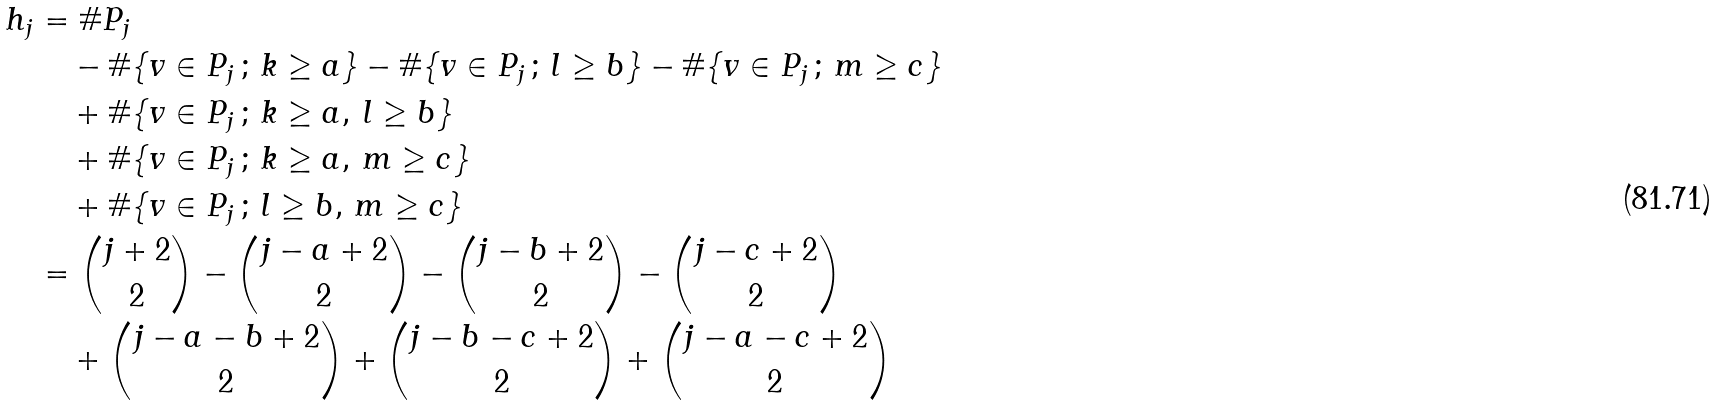Convert formula to latex. <formula><loc_0><loc_0><loc_500><loc_500>h _ { j } & = \# P _ { j } \\ & \quad - \# \{ v \in P _ { j } \, ; \, k \geq a \} - \# \{ v \in P _ { j } \, ; \, l \geq b \} - \# \{ v \in P _ { j } \, ; \, m \geq c \} \\ & \quad + \# \{ v \in P _ { j } \, ; \, k \geq a , \, l \geq b \} \\ & \quad + \# \{ v \in P _ { j } \, ; \, k \geq a , \, m \geq c \} \\ & \quad + \# \{ v \in P _ { j } \, ; \, l \geq b , \, m \geq c \} \\ & = \binom { j + 2 } { 2 } - \binom { j - a + 2 } { 2 } - \binom { j - b + 2 } { 2 } - \binom { j - c + 2 } { 2 } \\ & \quad + \binom { j - a - b + 2 } { 2 } + \binom { j - b - c + 2 } { 2 } + \binom { j - a - c + 2 } { 2 }</formula> 